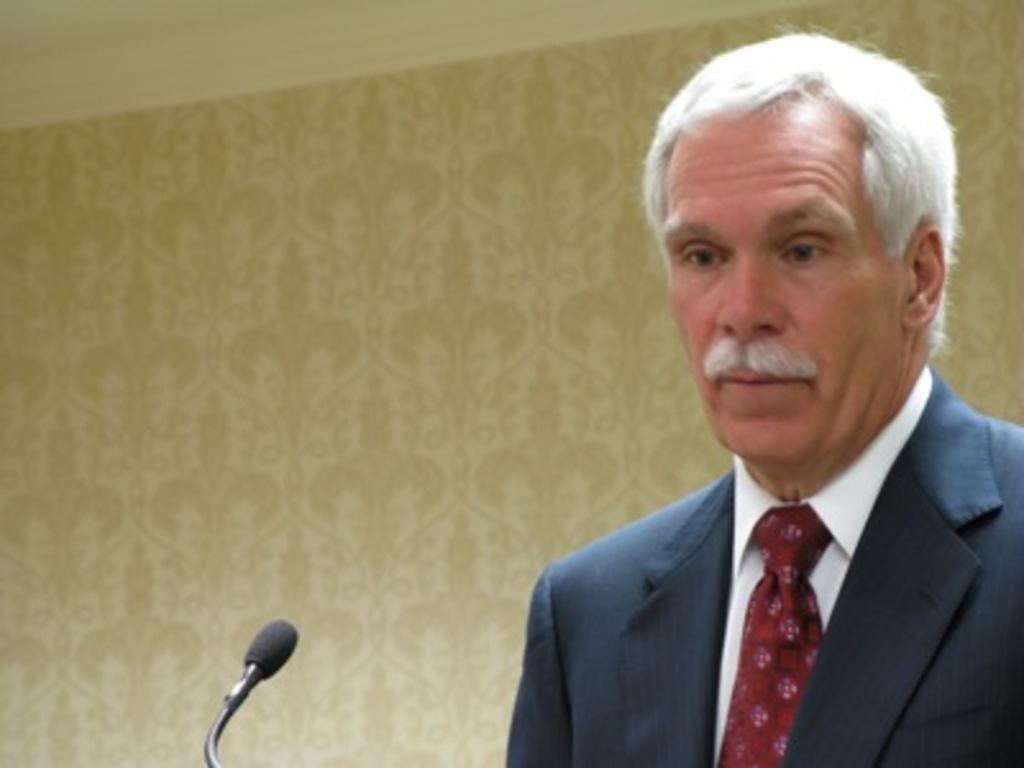Can you describe this image briefly? In this image on the right side there is one person in front of him there is one mike it seems that he is talking, in the background there is a wall. 